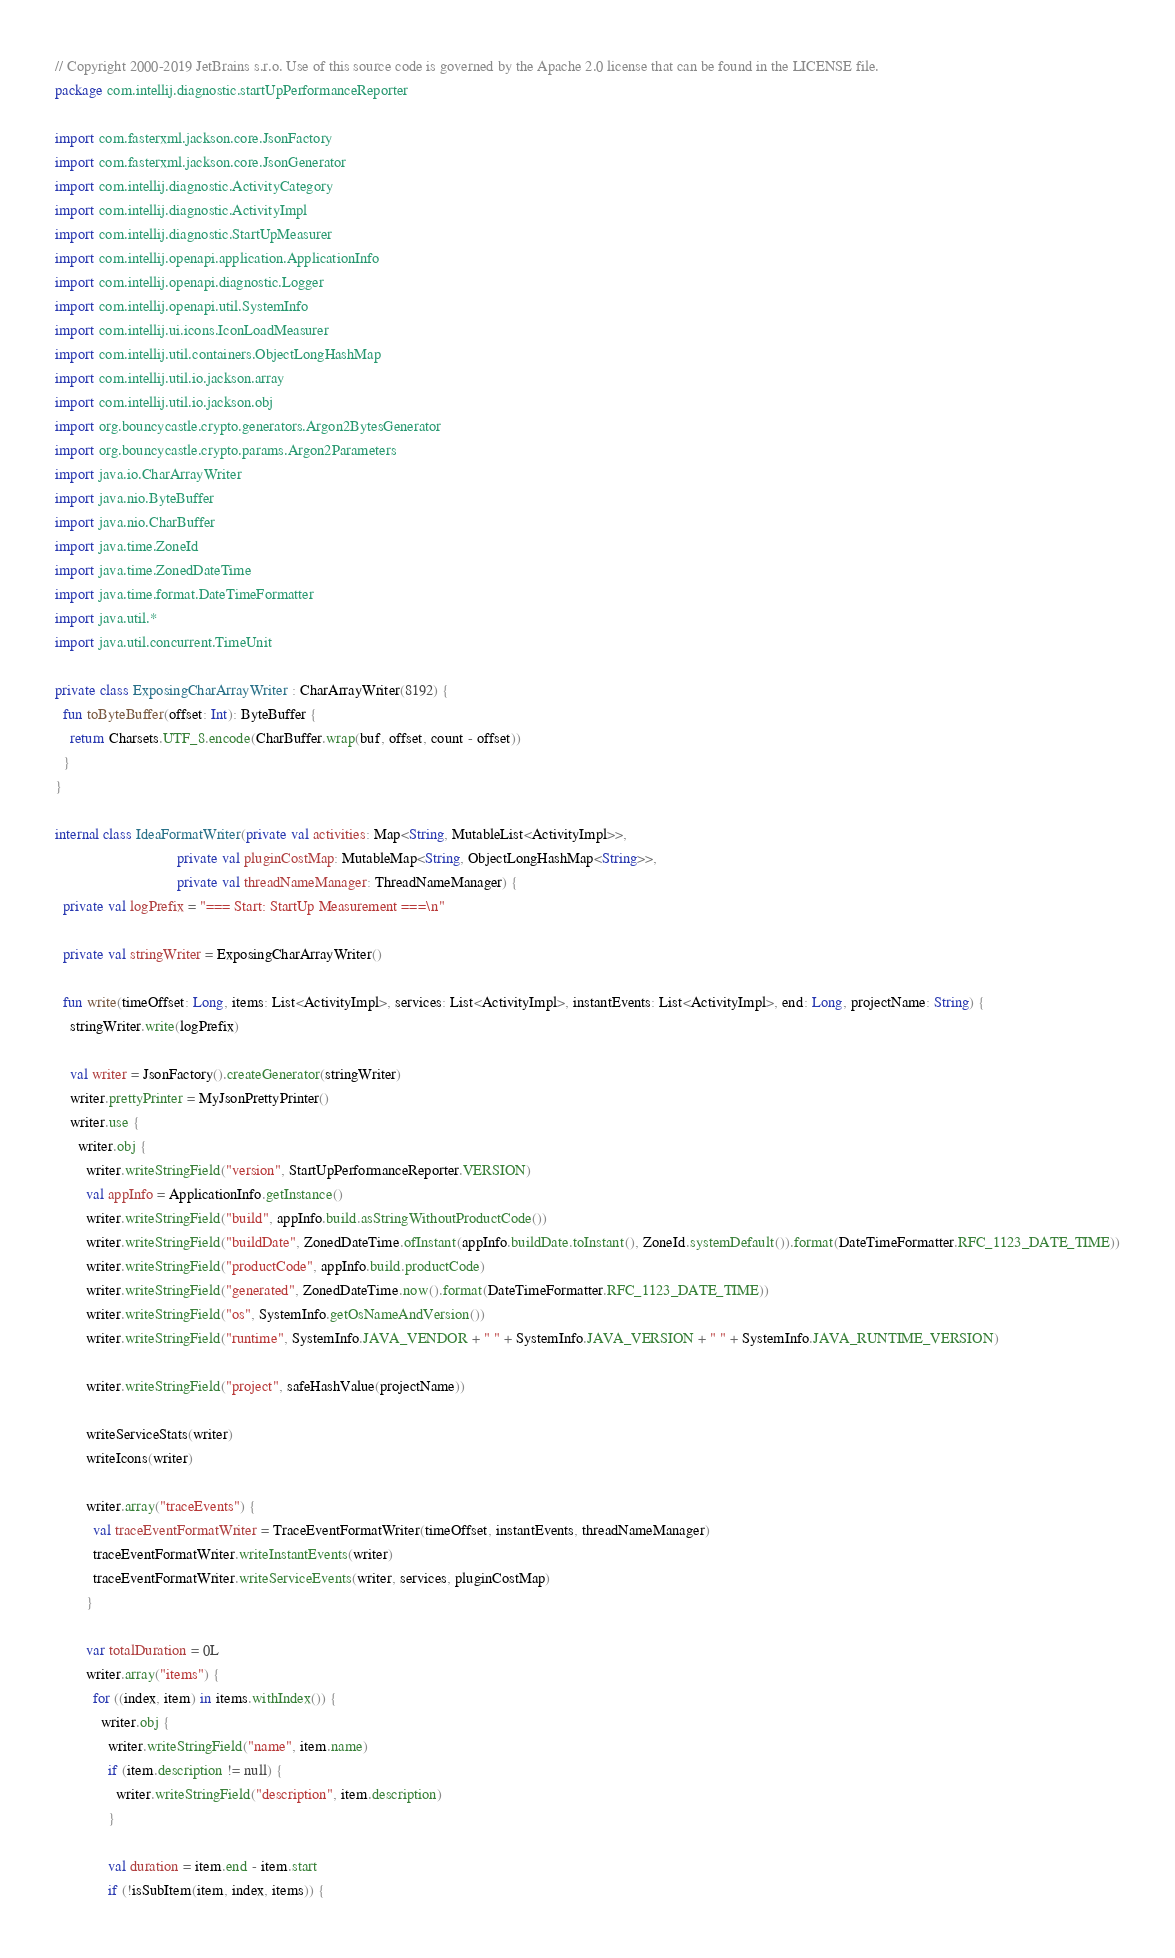Convert code to text. <code><loc_0><loc_0><loc_500><loc_500><_Kotlin_>// Copyright 2000-2019 JetBrains s.r.o. Use of this source code is governed by the Apache 2.0 license that can be found in the LICENSE file.
package com.intellij.diagnostic.startUpPerformanceReporter

import com.fasterxml.jackson.core.JsonFactory
import com.fasterxml.jackson.core.JsonGenerator
import com.intellij.diagnostic.ActivityCategory
import com.intellij.diagnostic.ActivityImpl
import com.intellij.diagnostic.StartUpMeasurer
import com.intellij.openapi.application.ApplicationInfo
import com.intellij.openapi.diagnostic.Logger
import com.intellij.openapi.util.SystemInfo
import com.intellij.ui.icons.IconLoadMeasurer
import com.intellij.util.containers.ObjectLongHashMap
import com.intellij.util.io.jackson.array
import com.intellij.util.io.jackson.obj
import org.bouncycastle.crypto.generators.Argon2BytesGenerator
import org.bouncycastle.crypto.params.Argon2Parameters
import java.io.CharArrayWriter
import java.nio.ByteBuffer
import java.nio.CharBuffer
import java.time.ZoneId
import java.time.ZonedDateTime
import java.time.format.DateTimeFormatter
import java.util.*
import java.util.concurrent.TimeUnit

private class ExposingCharArrayWriter : CharArrayWriter(8192) {
  fun toByteBuffer(offset: Int): ByteBuffer {
    return Charsets.UTF_8.encode(CharBuffer.wrap(buf, offset, count - offset))
  }
}

internal class IdeaFormatWriter(private val activities: Map<String, MutableList<ActivityImpl>>,
                                private val pluginCostMap: MutableMap<String, ObjectLongHashMap<String>>,
                                private val threadNameManager: ThreadNameManager) {
  private val logPrefix = "=== Start: StartUp Measurement ===\n"

  private val stringWriter = ExposingCharArrayWriter()

  fun write(timeOffset: Long, items: List<ActivityImpl>, services: List<ActivityImpl>, instantEvents: List<ActivityImpl>, end: Long, projectName: String) {
    stringWriter.write(logPrefix)

    val writer = JsonFactory().createGenerator(stringWriter)
    writer.prettyPrinter = MyJsonPrettyPrinter()
    writer.use {
      writer.obj {
        writer.writeStringField("version", StartUpPerformanceReporter.VERSION)
        val appInfo = ApplicationInfo.getInstance()
        writer.writeStringField("build", appInfo.build.asStringWithoutProductCode())
        writer.writeStringField("buildDate", ZonedDateTime.ofInstant(appInfo.buildDate.toInstant(), ZoneId.systemDefault()).format(DateTimeFormatter.RFC_1123_DATE_TIME))
        writer.writeStringField("productCode", appInfo.build.productCode)
        writer.writeStringField("generated", ZonedDateTime.now().format(DateTimeFormatter.RFC_1123_DATE_TIME))
        writer.writeStringField("os", SystemInfo.getOsNameAndVersion())
        writer.writeStringField("runtime", SystemInfo.JAVA_VENDOR + " " + SystemInfo.JAVA_VERSION + " " + SystemInfo.JAVA_RUNTIME_VERSION)

        writer.writeStringField("project", safeHashValue(projectName))

        writeServiceStats(writer)
        writeIcons(writer)

        writer.array("traceEvents") {
          val traceEventFormatWriter = TraceEventFormatWriter(timeOffset, instantEvents, threadNameManager)
          traceEventFormatWriter.writeInstantEvents(writer)
          traceEventFormatWriter.writeServiceEvents(writer, services, pluginCostMap)
        }

        var totalDuration = 0L
        writer.array("items") {
          for ((index, item) in items.withIndex()) {
            writer.obj {
              writer.writeStringField("name", item.name)
              if (item.description != null) {
                writer.writeStringField("description", item.description)
              }

              val duration = item.end - item.start
              if (!isSubItem(item, index, items)) {</code> 